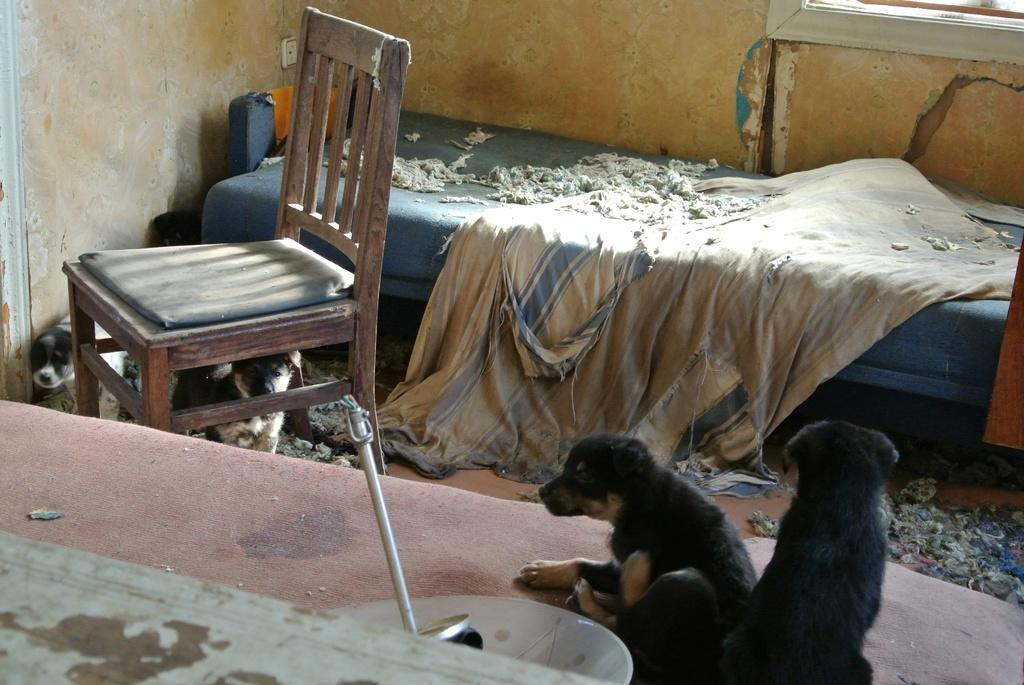What type of furniture is present in the image? There is a chair and a bed in the image. What living creatures can be seen in the image? There are puppies in the image. How many rabbits are sitting on the branch in the image? There are no rabbits or branches present in the image. 